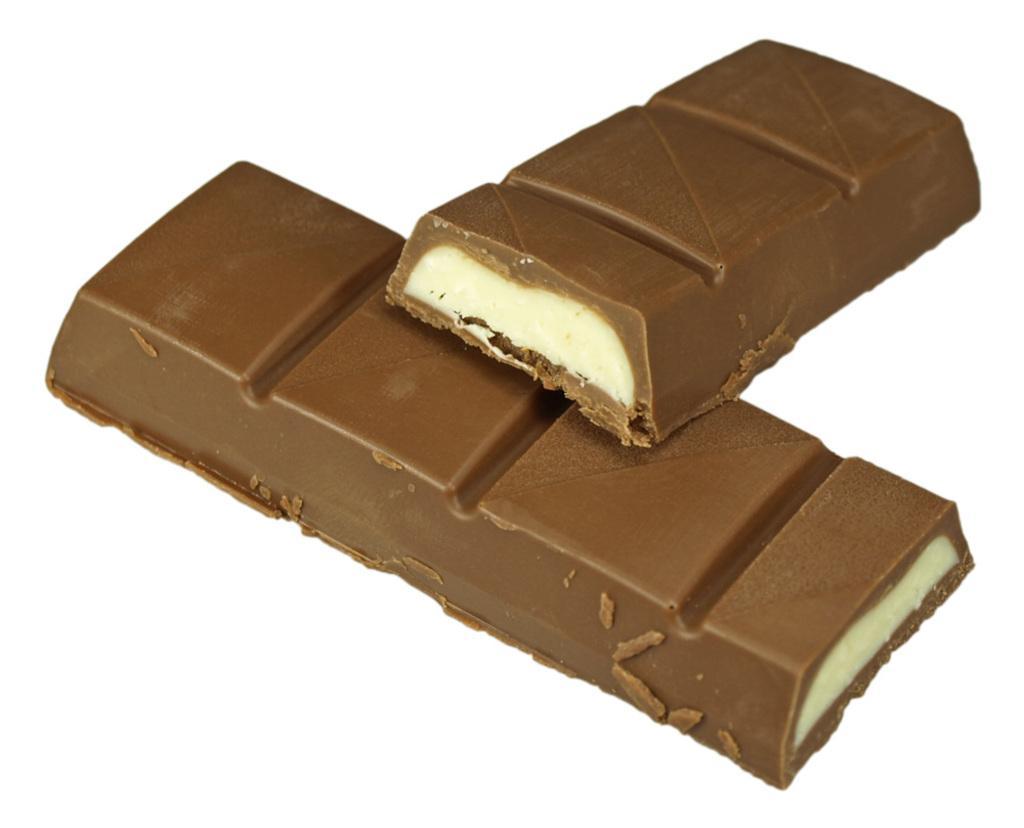Can you describe this image briefly? In this image there are two bites of caramel chocolates one above the other. 